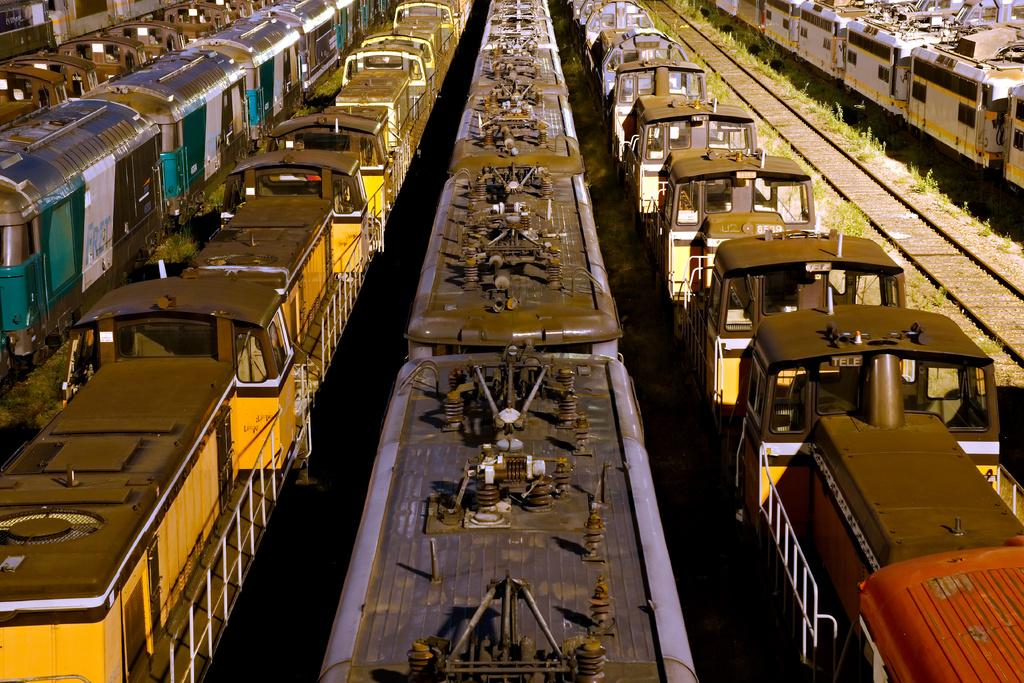What type of vehicles are present in the image? There are trains in the image. Where are the trains located? The trains are on train tracks. What can be seen on either side of the train tracks? There are tiny plants on either side of the train tracks. What type of toy can be seen playing with a glove in the image? There is no toy or glove present in the image; it features trains on train tracks with tiny plants on either side. 